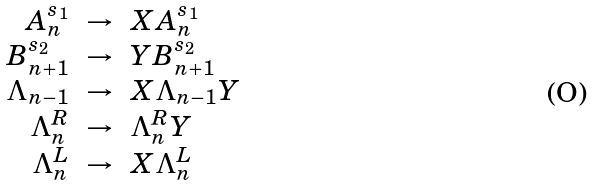Convert formula to latex. <formula><loc_0><loc_0><loc_500><loc_500>\begin{array} { r c l } A _ { n } ^ { s _ { 1 } } & \rightarrow & X A _ { n } ^ { s _ { 1 } } \\ B _ { n + 1 } ^ { s _ { 2 } } & \rightarrow & Y B _ { n + 1 } ^ { s _ { 2 } } \\ \Lambda _ { n - 1 } & \rightarrow & X \Lambda _ { n - 1 } Y \\ \Lambda ^ { R } _ { n } & \rightarrow & \Lambda ^ { R } _ { n } Y \\ \Lambda ^ { L } _ { n } & \rightarrow & X \Lambda ^ { L } _ { n } \\ \end{array}</formula> 